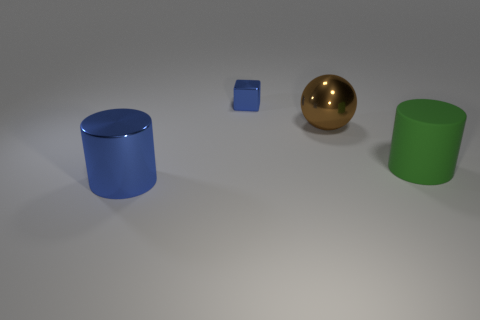Add 4 small blue objects. How many objects exist? 8 Subtract all blocks. How many objects are left? 3 Add 4 tiny blue balls. How many tiny blue balls exist? 4 Subtract 0 yellow cylinders. How many objects are left? 4 Subtract all small yellow balls. Subtract all big green matte cylinders. How many objects are left? 3 Add 4 green cylinders. How many green cylinders are left? 5 